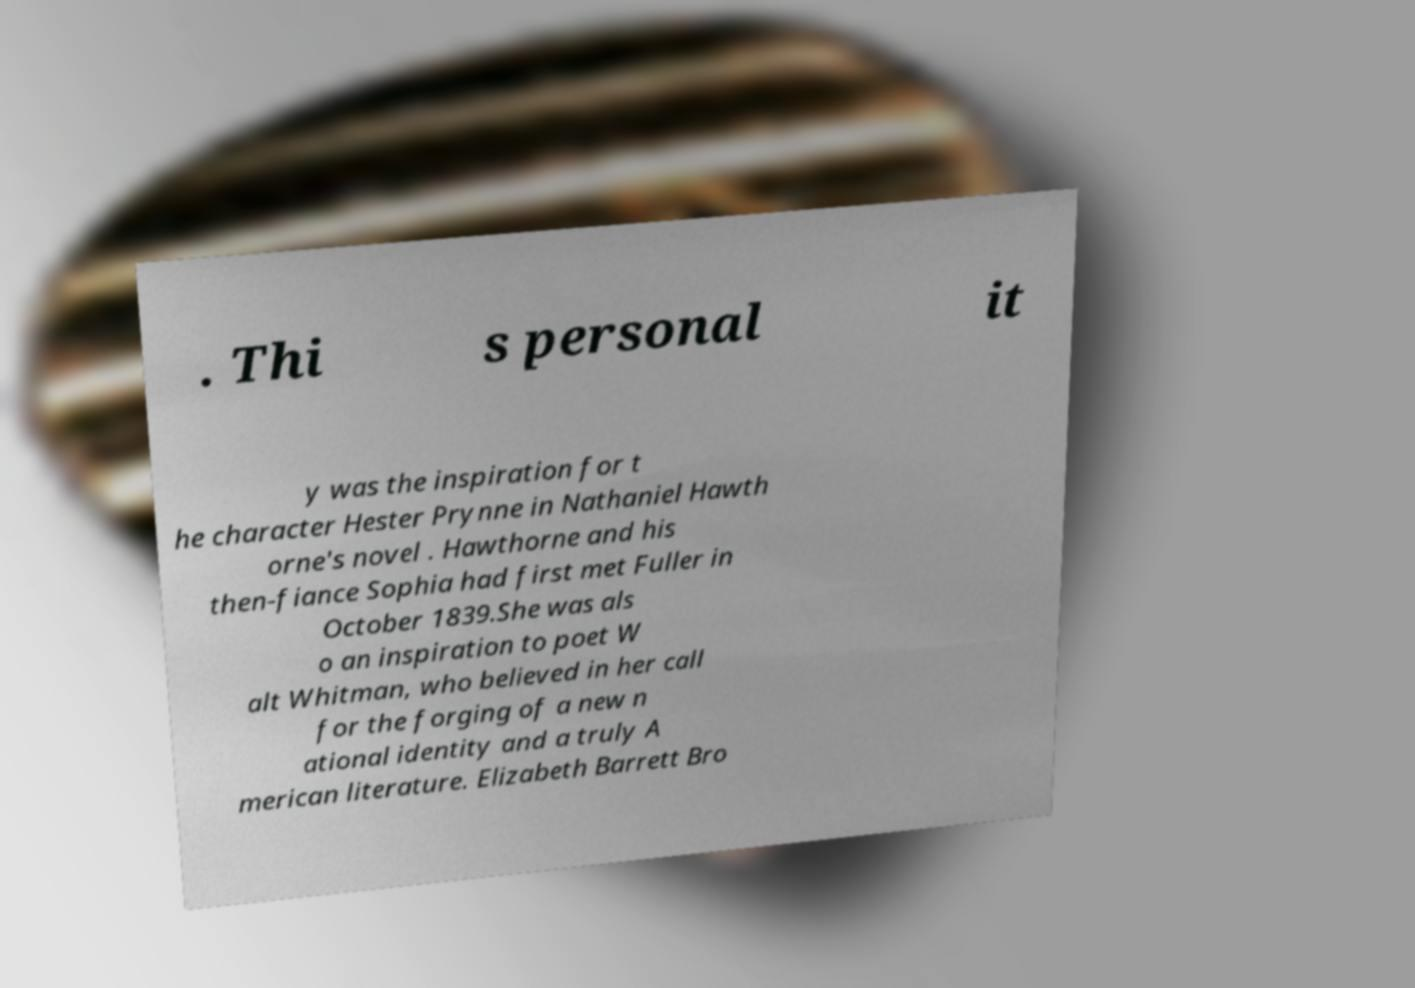Can you accurately transcribe the text from the provided image for me? . Thi s personal it y was the inspiration for t he character Hester Prynne in Nathaniel Hawth orne's novel . Hawthorne and his then-fiance Sophia had first met Fuller in October 1839.She was als o an inspiration to poet W alt Whitman, who believed in her call for the forging of a new n ational identity and a truly A merican literature. Elizabeth Barrett Bro 